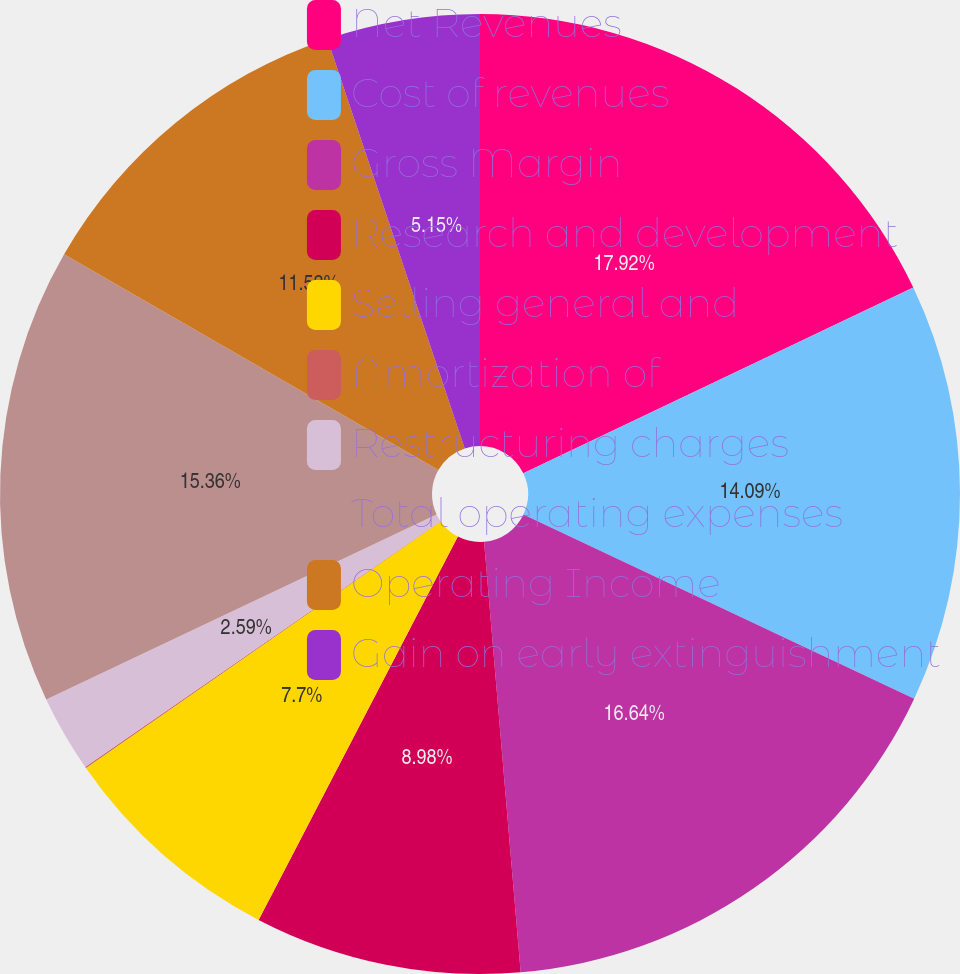Convert chart to OTSL. <chart><loc_0><loc_0><loc_500><loc_500><pie_chart><fcel>Net Revenues<fcel>Cost of revenues<fcel>Gross Margin<fcel>Research and development<fcel>Selling general and<fcel>Amortization of<fcel>Restructuring charges<fcel>Total operating expenses<fcel>Operating Income<fcel>Gain on early extinguishment<nl><fcel>17.92%<fcel>14.09%<fcel>16.64%<fcel>8.98%<fcel>7.7%<fcel>0.04%<fcel>2.59%<fcel>15.36%<fcel>11.53%<fcel>5.15%<nl></chart> 